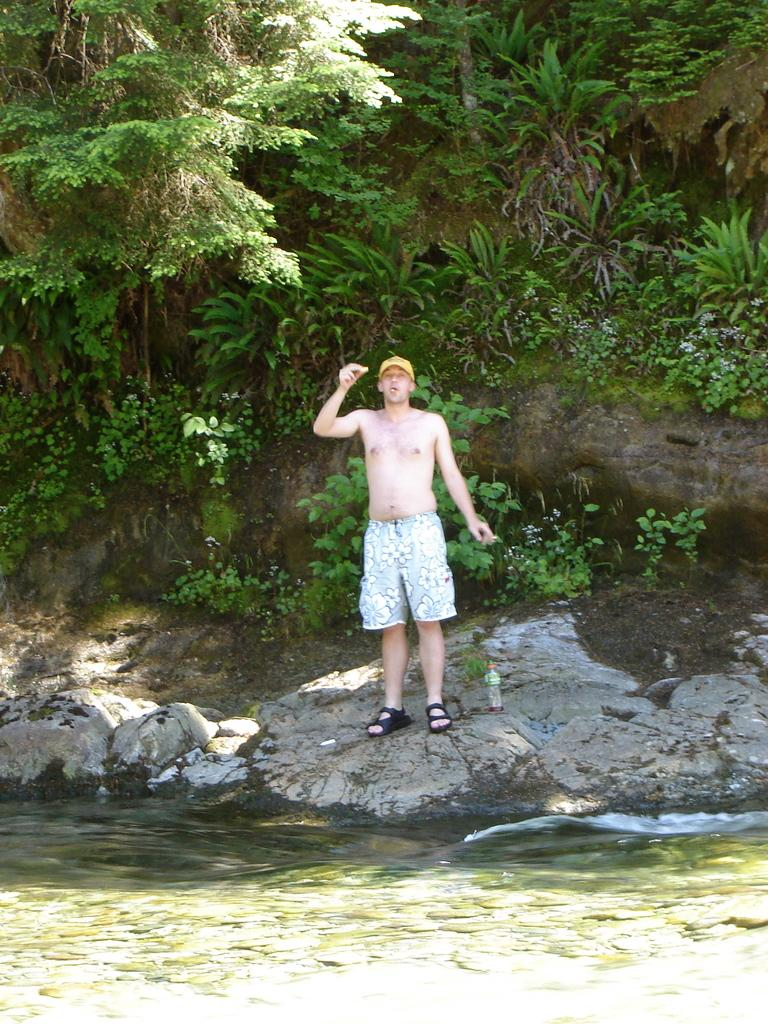What is the main subject of the image? There is a person standing in the image. What is the person wearing? The person is wearing white-colored shorts. What can be seen in the background of the image? There are trees in the background of the image. What is the color of the trees? The trees are green in color. What else is visible in the image besides the person and trees? There is water visible in the image. What type of doll is floating on the water in the image? There is no doll present in the image; it only features a person standing, green trees in the background, and water. 